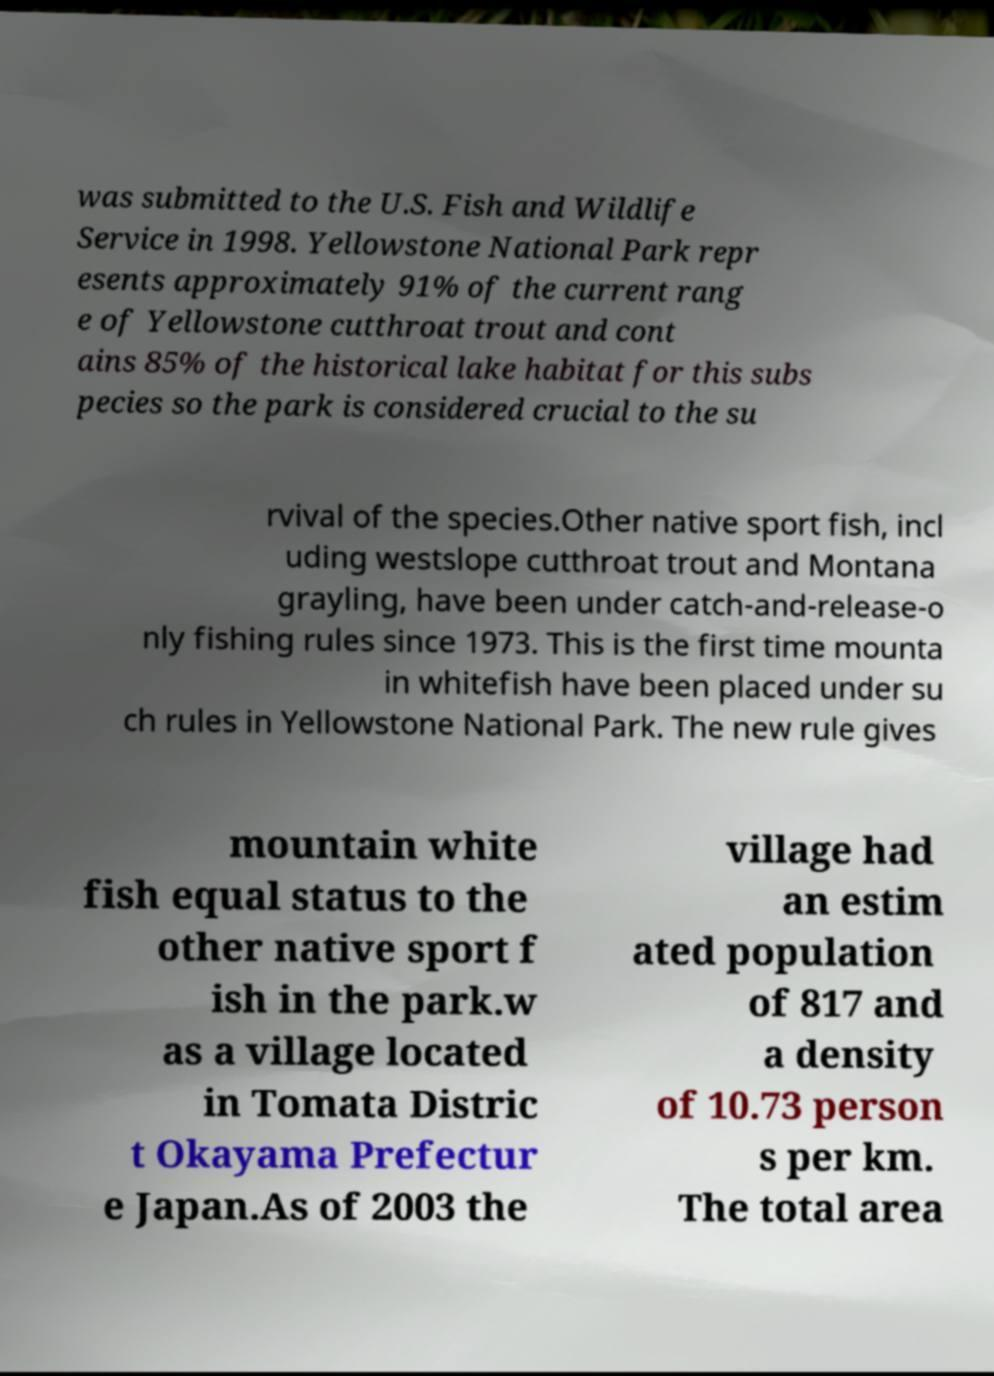For documentation purposes, I need the text within this image transcribed. Could you provide that? was submitted to the U.S. Fish and Wildlife Service in 1998. Yellowstone National Park repr esents approximately 91% of the current rang e of Yellowstone cutthroat trout and cont ains 85% of the historical lake habitat for this subs pecies so the park is considered crucial to the su rvival of the species.Other native sport fish, incl uding westslope cutthroat trout and Montana grayling, have been under catch-and-release-o nly fishing rules since 1973. This is the first time mounta in whitefish have been placed under su ch rules in Yellowstone National Park. The new rule gives mountain white fish equal status to the other native sport f ish in the park.w as a village located in Tomata Distric t Okayama Prefectur e Japan.As of 2003 the village had an estim ated population of 817 and a density of 10.73 person s per km. The total area 